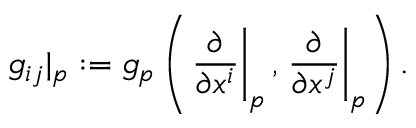<formula> <loc_0><loc_0><loc_500><loc_500>g _ { i j } | _ { p } \colon = g _ { p } \left ( { \frac { \partial } { \partial x ^ { i } } } \right | _ { p } , { \frac { \partial } { \partial x ^ { j } } } \right | _ { p } \right ) .</formula> 